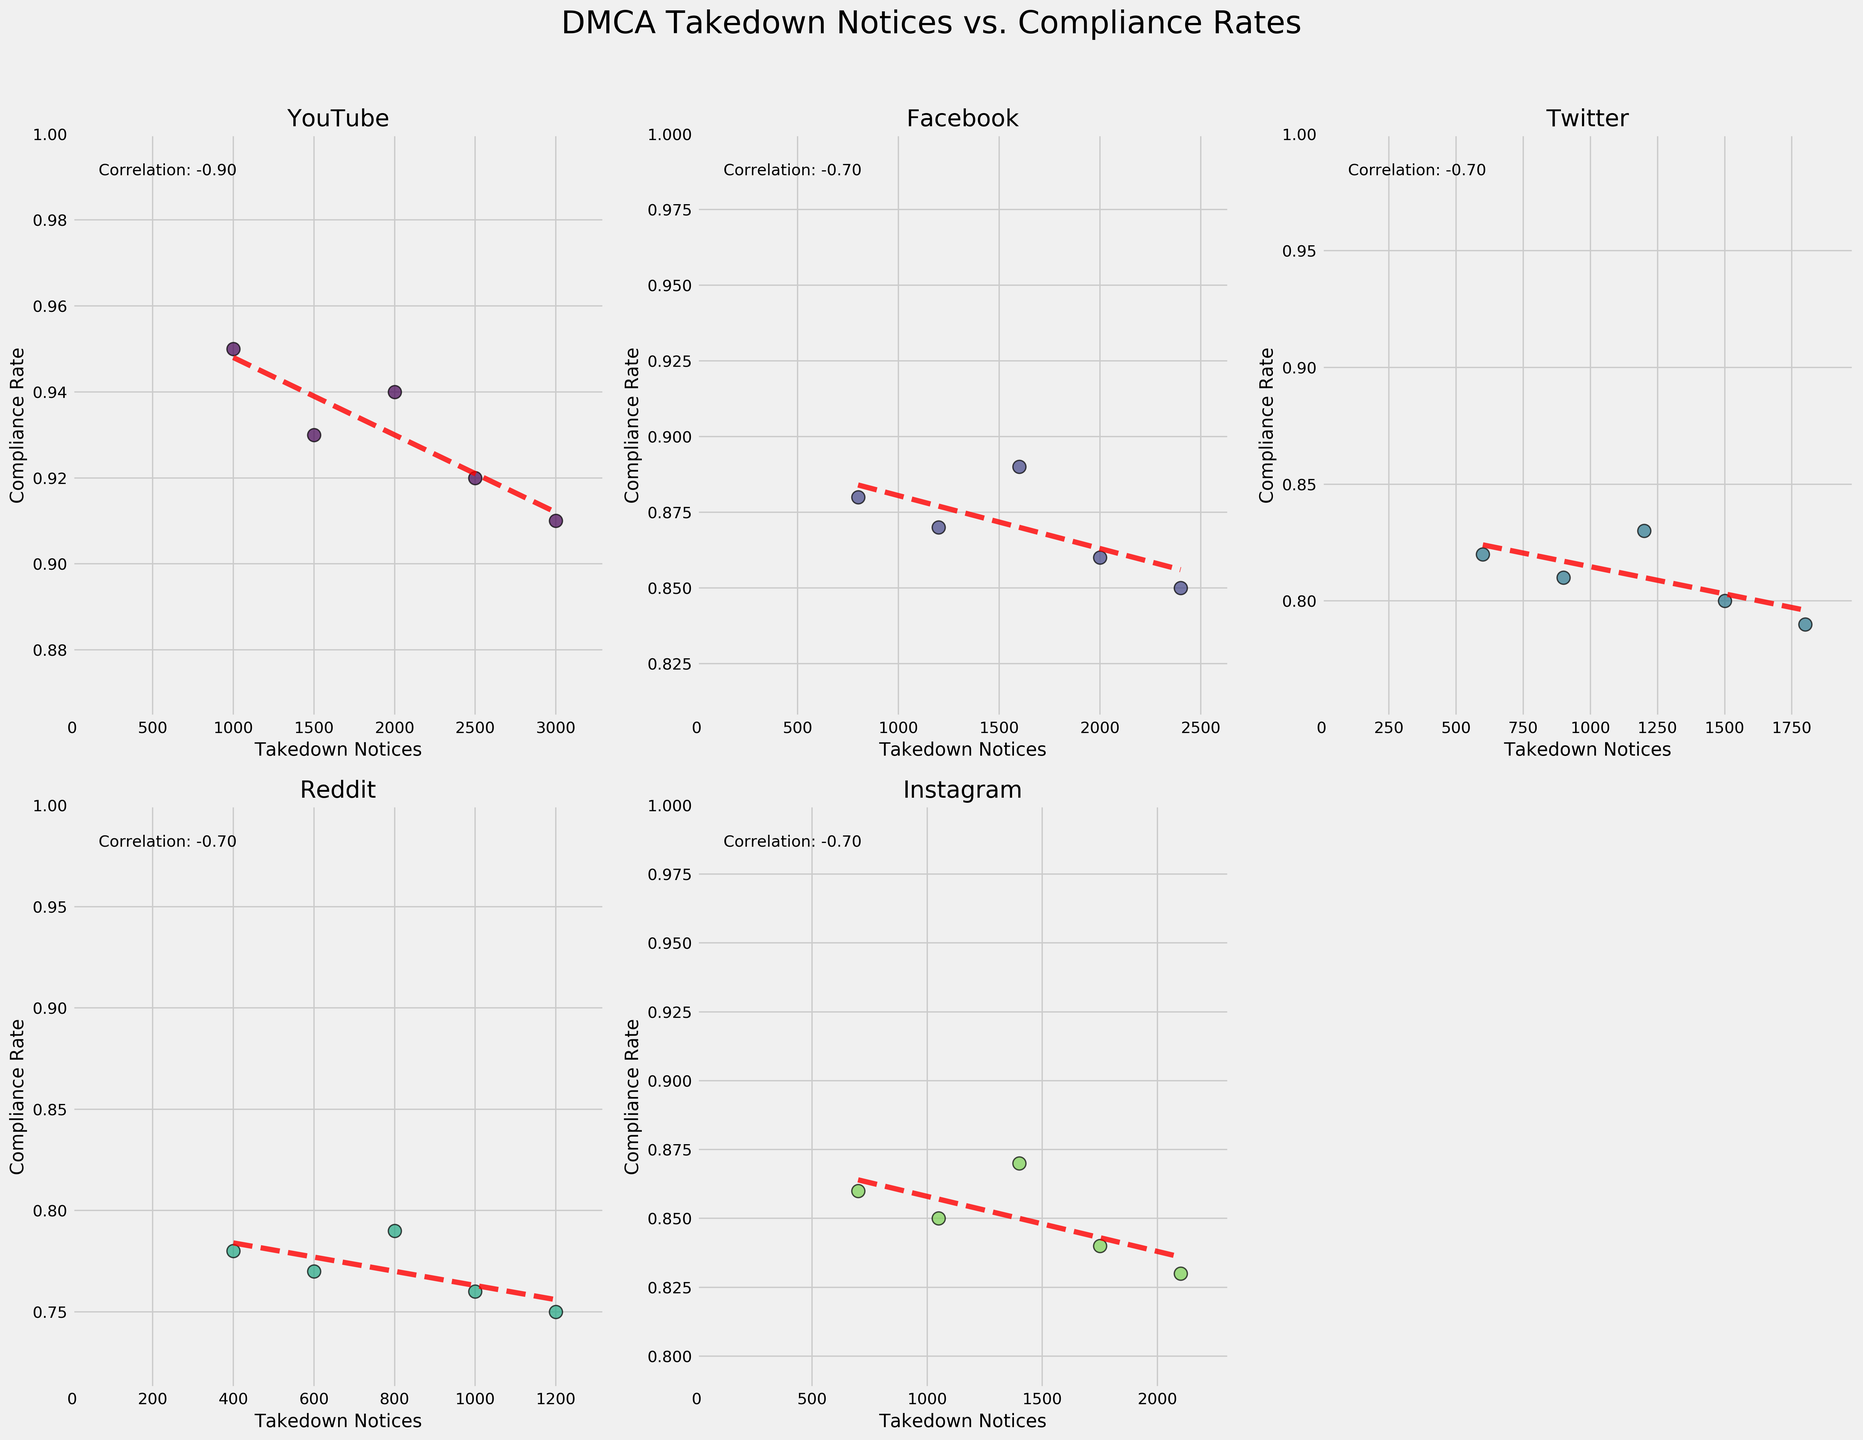What is the correlation coefficient for YouTube? Locate YouTube's subplot and find the text indicating the correlation coefficient. It is written in the upper right corner of YouTube's subplot.
Answer: 0.80 Which platform shows the highest compliance rate for the highest number of takedown notices? For each platform's subplot, locate the data point with the maximum number of takedown notices and observe their corresponding compliance rates. The highest compliance rate for the maximum number of takedown notices is from YouTube with 0.91 compliance rate at 3000 notices.
Answer: YouTube Which platform has the lowest compliance rate for any number of takedown notices? Scan all subplot data points to identify the platform with the lowest compliance rate value. Reddit has the lowest compliance rate of 0.75 at 1200 notices.
Answer: Reddit What trend do you observe in the compliance rate as the number of takedown notices increases on Facebook? Observe the trend line over the data points in Facebook's subplot. The slope of the trend line shows a decreasing trend as the number of takedown notices increases.
Answer: Decreasing For which platform is the compliance rate most sensitive to the number of takedown notices? Compare the slopes of the trend lines across subplots to determine which platform's compliance rate changes the most with takedown notices. Twitter's trend line has the steepest negative slope indicating the highest sensitivity.
Answer: Twitter Which platform shows the smallest range in compliance rates? Determine the range of compliance rates for each subplot by finding the difference between maximum and minimum values of compliance rate. TikTok has compliance rates ranging from 0.86 to 0.90, which is the least range.
Answer: TikTok 